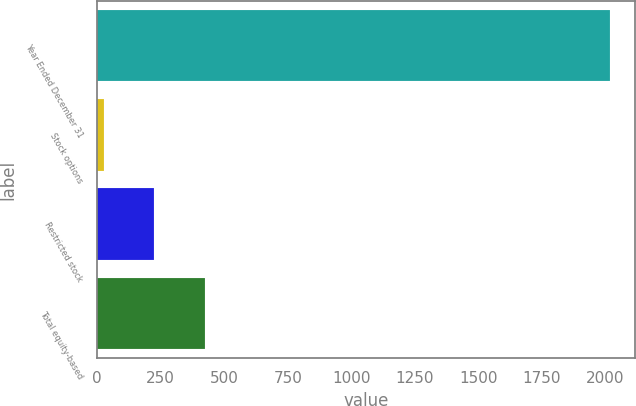<chart> <loc_0><loc_0><loc_500><loc_500><bar_chart><fcel>Year Ended December 31<fcel>Stock options<fcel>Restricted stock<fcel>Total equity-based<nl><fcel>2016<fcel>25<fcel>224.1<fcel>423.2<nl></chart> 